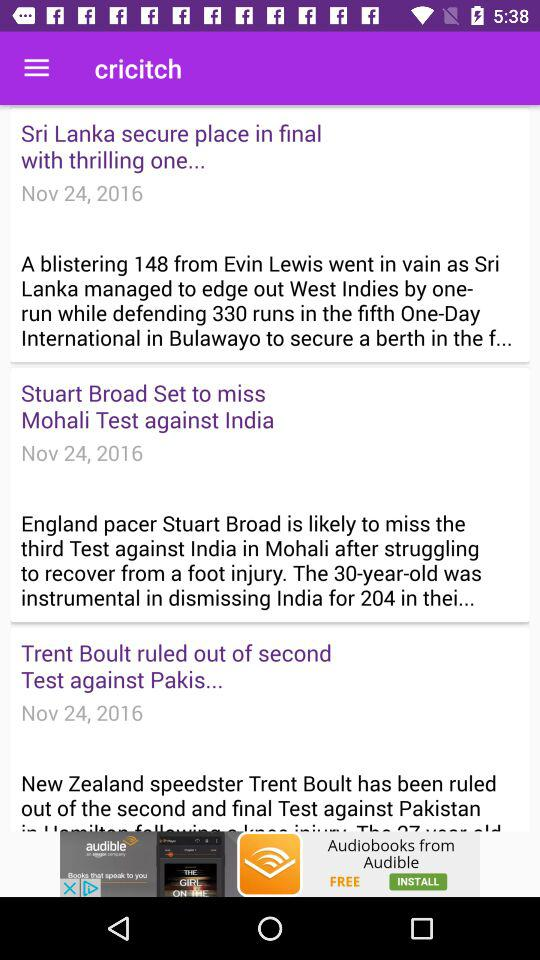How many wickets did Australia win by?
Answer the question using a single word or phrase. 7 